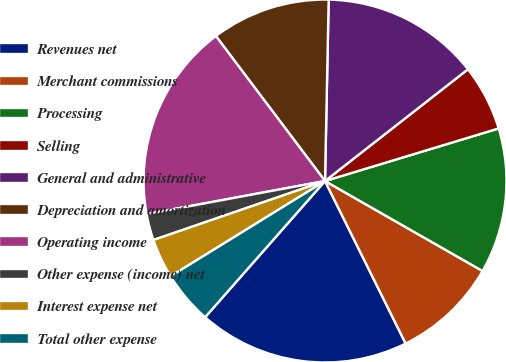Convert chart to OTSL. <chart><loc_0><loc_0><loc_500><loc_500><pie_chart><fcel>Revenues net<fcel>Merchant commissions<fcel>Processing<fcel>Selling<fcel>General and administrative<fcel>Depreciation and amortization<fcel>Operating income<fcel>Other expense (income) net<fcel>Interest expense net<fcel>Total other expense<nl><fcel>18.82%<fcel>9.41%<fcel>12.94%<fcel>5.88%<fcel>14.12%<fcel>10.59%<fcel>17.65%<fcel>2.35%<fcel>3.53%<fcel>4.71%<nl></chart> 